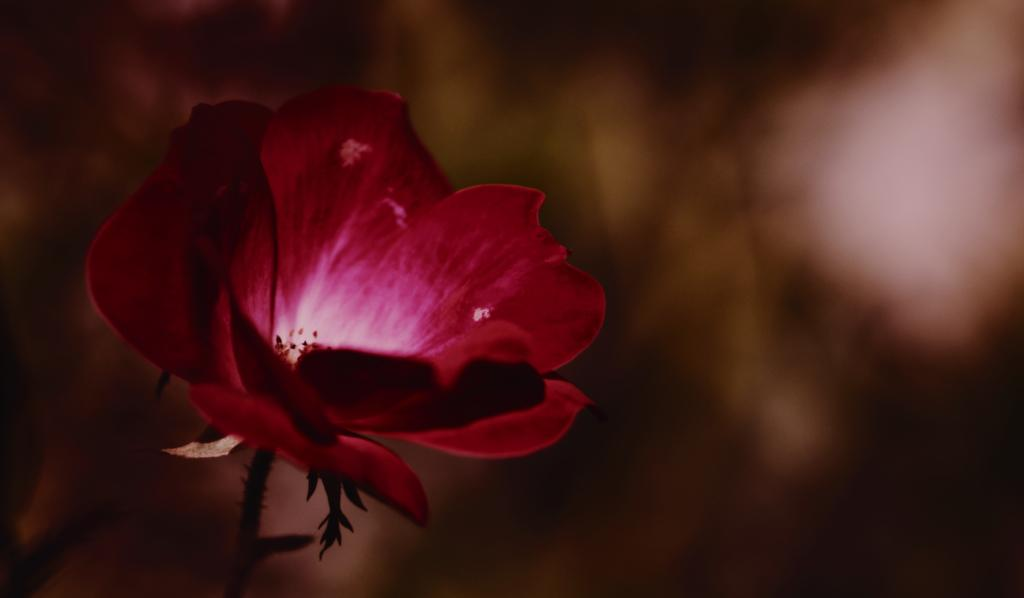What is the main subject of the image? The main subject of the image is a flower. Can you describe the flower in more detail? Yes, the flower has a stem. What is the color of the background in the image? The background of the image is dark. What type of underwear is hanging on the flower in the image? There is no underwear present in the image; it features a flower with a stem against a dark background. 